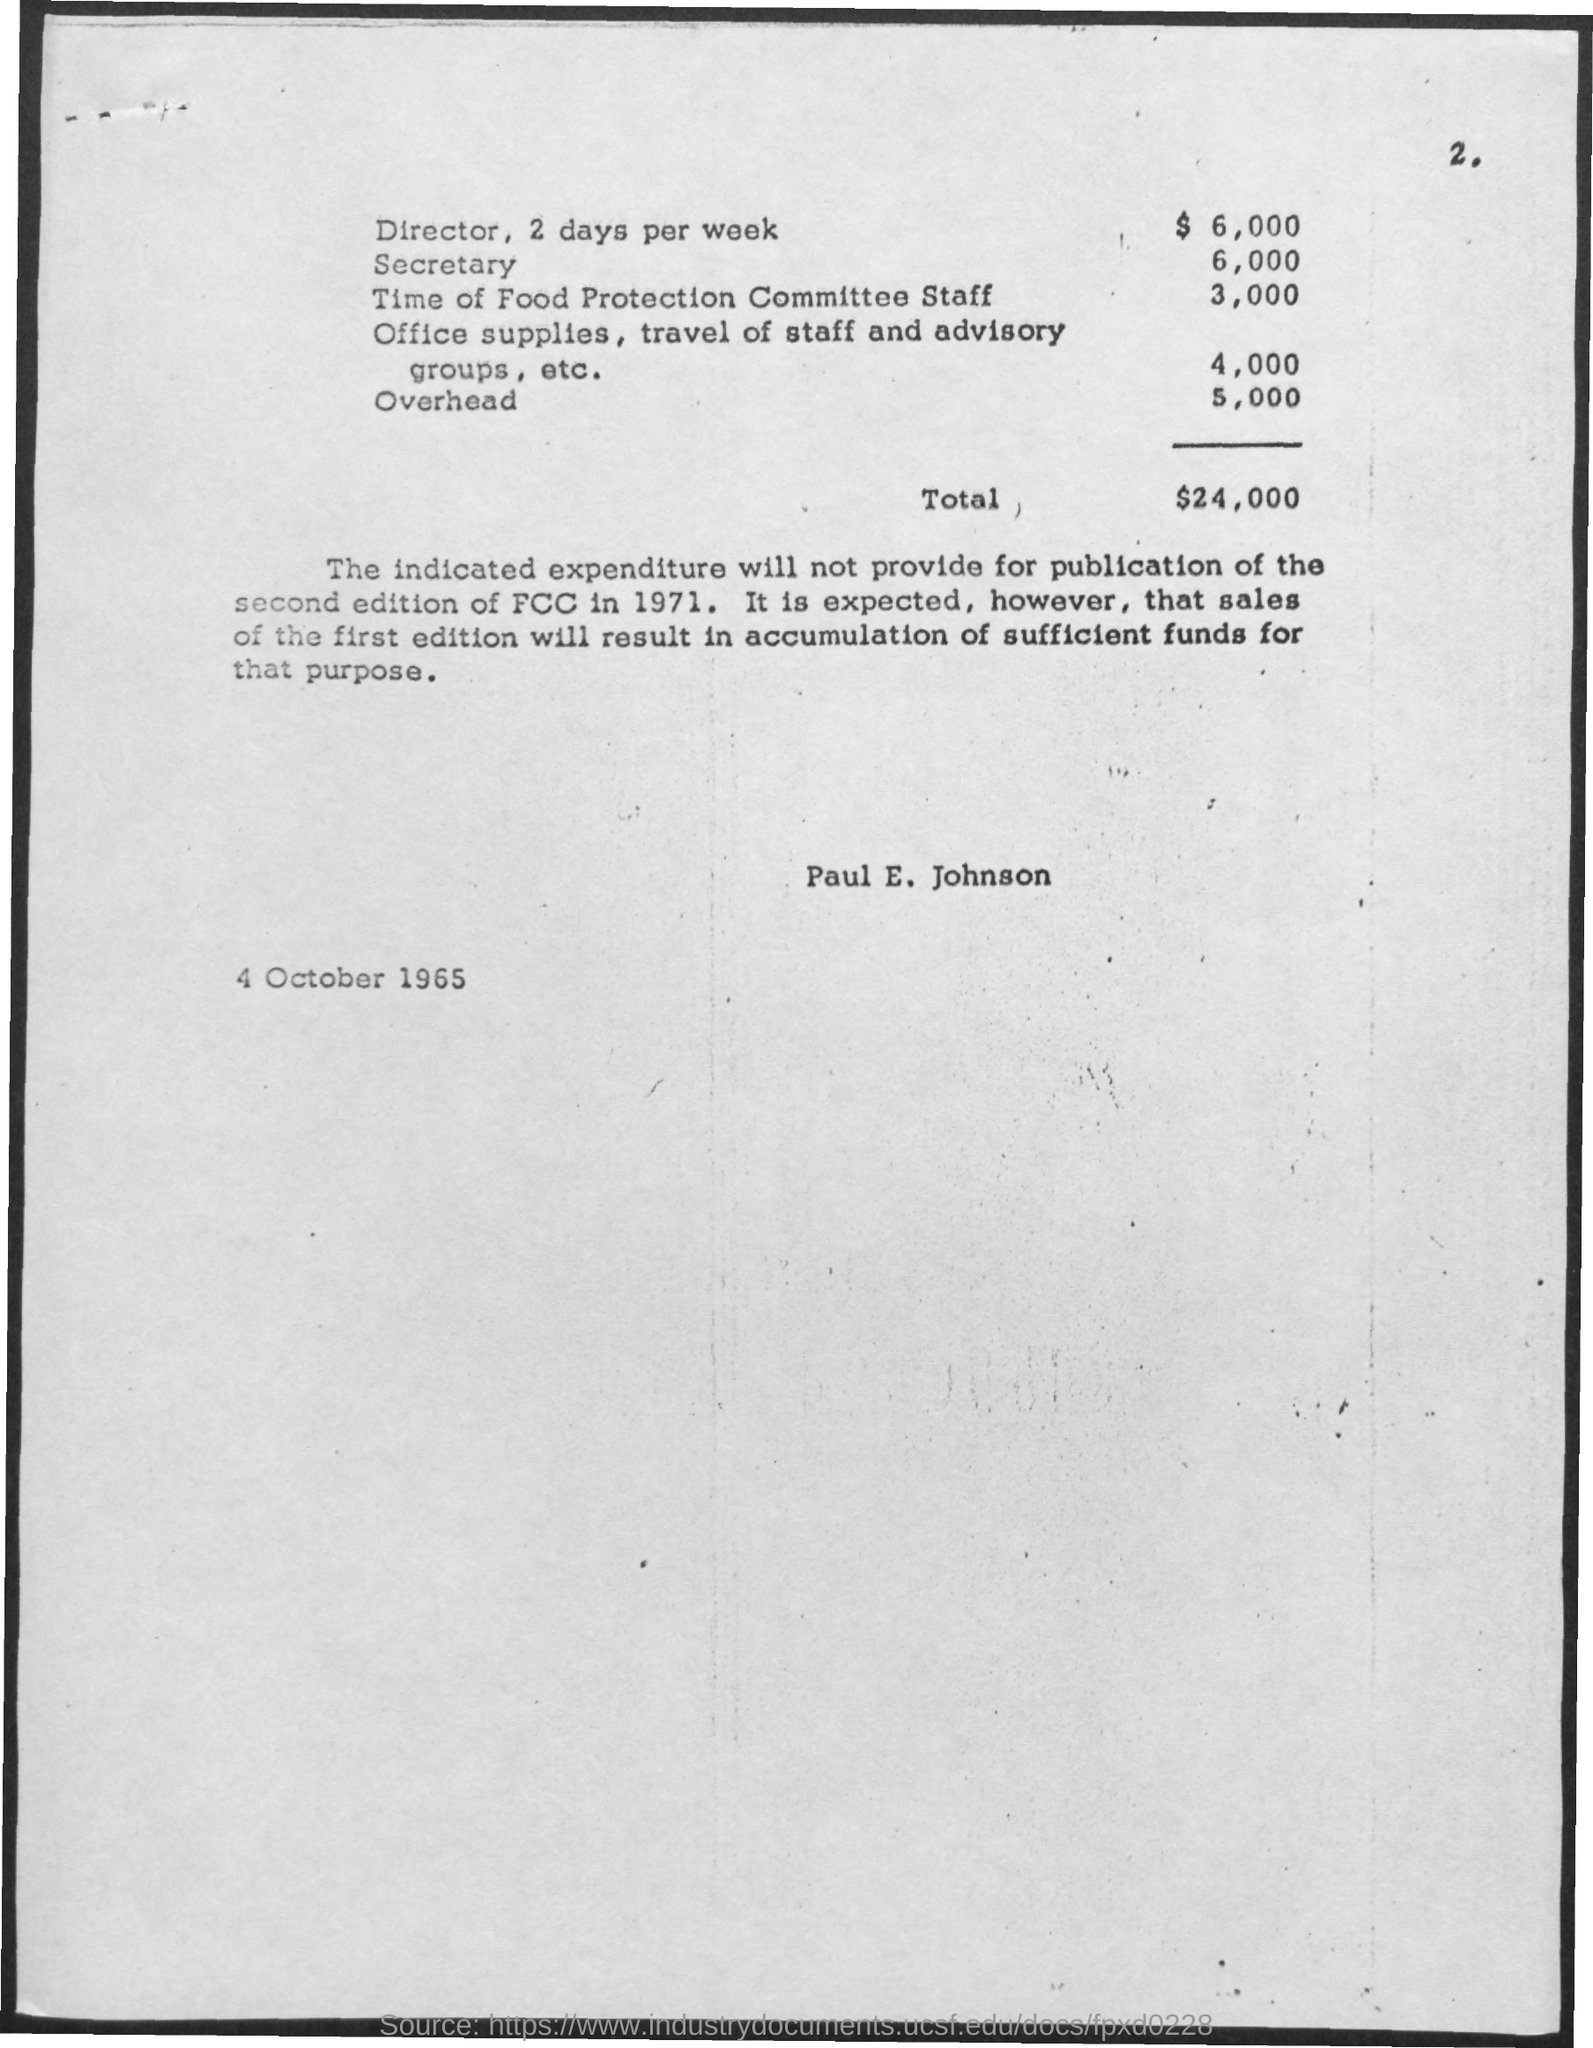Identify some key points in this picture. The page number of the document is 2. The total amount of expenditure is 24,000. The expenditure for the time of the Food Protection Committee Staff is $3,000. The date and year mentioned in the page are 4 October 1965. The expenditure for the Secretary is $6,000. 